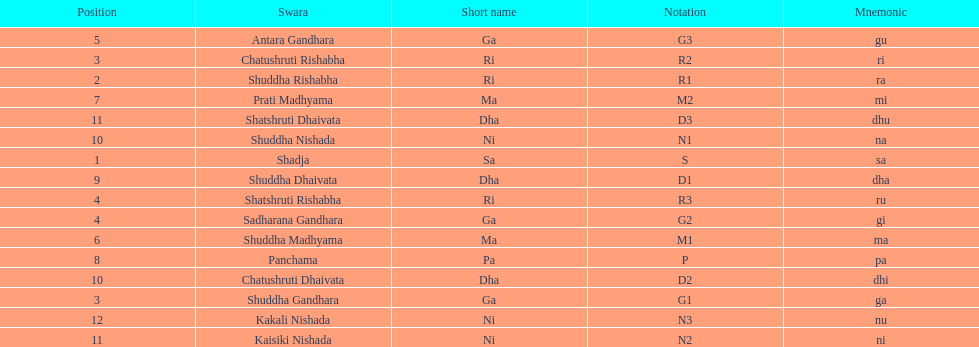On average how many of the swara have a short name that begin with d or g? 6. Give me the full table as a dictionary. {'header': ['Position', 'Swara', 'Short name', 'Notation', 'Mnemonic'], 'rows': [['5', 'Antara Gandhara', 'Ga', 'G3', 'gu'], ['3', 'Chatushruti Rishabha', 'Ri', 'R2', 'ri'], ['2', 'Shuddha Rishabha', 'Ri', 'R1', 'ra'], ['7', 'Prati Madhyama', 'Ma', 'M2', 'mi'], ['11', 'Shatshruti Dhaivata', 'Dha', 'D3', 'dhu'], ['10', 'Shuddha Nishada', 'Ni', 'N1', 'na'], ['1', 'Shadja', 'Sa', 'S', 'sa'], ['9', 'Shuddha Dhaivata', 'Dha', 'D1', 'dha'], ['4', 'Shatshruti Rishabha', 'Ri', 'R3', 'ru'], ['4', 'Sadharana Gandhara', 'Ga', 'G2', 'gi'], ['6', 'Shuddha Madhyama', 'Ma', 'M1', 'ma'], ['8', 'Panchama', 'Pa', 'P', 'pa'], ['10', 'Chatushruti Dhaivata', 'Dha', 'D2', 'dhi'], ['3', 'Shuddha Gandhara', 'Ga', 'G1', 'ga'], ['12', 'Kakali Nishada', 'Ni', 'N3', 'nu'], ['11', 'Kaisiki Nishada', 'Ni', 'N2', 'ni']]} 